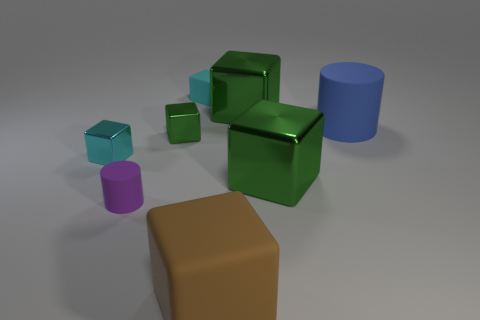Subtract all cyan cubes. How many were subtracted if there are1cyan cubes left? 1 Subtract all green cylinders. How many green blocks are left? 3 Subtract 2 blocks. How many blocks are left? 4 Subtract all cyan cubes. How many cubes are left? 4 Subtract all big rubber blocks. How many blocks are left? 5 Add 1 small cyan cubes. How many objects exist? 9 Subtract all gray cubes. Subtract all green balls. How many cubes are left? 6 Subtract all blocks. How many objects are left? 2 Subtract all small purple metallic cylinders. Subtract all small matte cylinders. How many objects are left? 7 Add 2 big blue rubber cylinders. How many big blue rubber cylinders are left? 3 